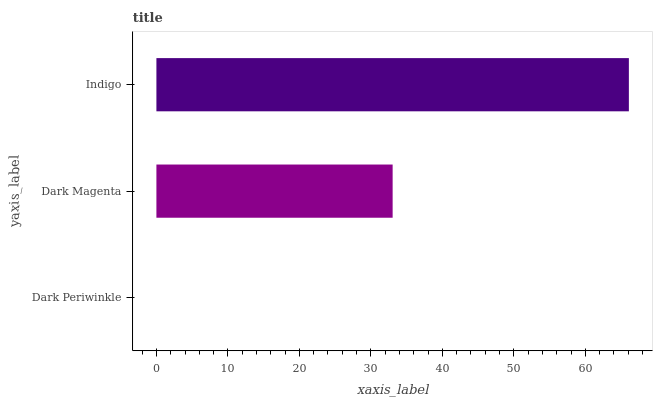Is Dark Periwinkle the minimum?
Answer yes or no. Yes. Is Indigo the maximum?
Answer yes or no. Yes. Is Dark Magenta the minimum?
Answer yes or no. No. Is Dark Magenta the maximum?
Answer yes or no. No. Is Dark Magenta greater than Dark Periwinkle?
Answer yes or no. Yes. Is Dark Periwinkle less than Dark Magenta?
Answer yes or no. Yes. Is Dark Periwinkle greater than Dark Magenta?
Answer yes or no. No. Is Dark Magenta less than Dark Periwinkle?
Answer yes or no. No. Is Dark Magenta the high median?
Answer yes or no. Yes. Is Dark Magenta the low median?
Answer yes or no. Yes. Is Indigo the high median?
Answer yes or no. No. Is Dark Periwinkle the low median?
Answer yes or no. No. 